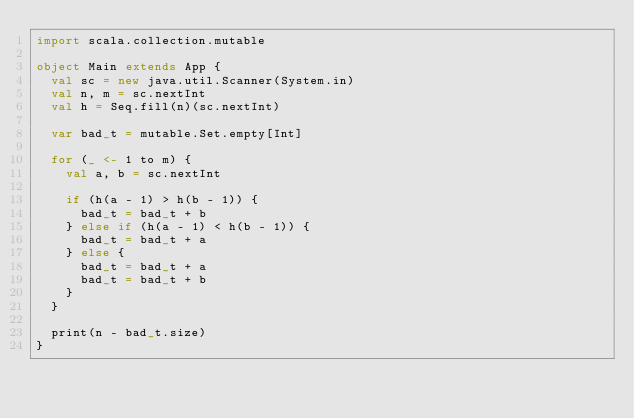Convert code to text. <code><loc_0><loc_0><loc_500><loc_500><_Scala_>import scala.collection.mutable

object Main extends App {
  val sc = new java.util.Scanner(System.in)
  val n, m = sc.nextInt
  val h = Seq.fill(n)(sc.nextInt)

  var bad_t = mutable.Set.empty[Int]

  for (_ <- 1 to m) {
    val a, b = sc.nextInt

    if (h(a - 1) > h(b - 1)) {
      bad_t = bad_t + b
    } else if (h(a - 1) < h(b - 1)) {
      bad_t = bad_t + a
    } else {
      bad_t = bad_t + a
      bad_t = bad_t + b
    }
  }

  print(n - bad_t.size)
}
</code> 